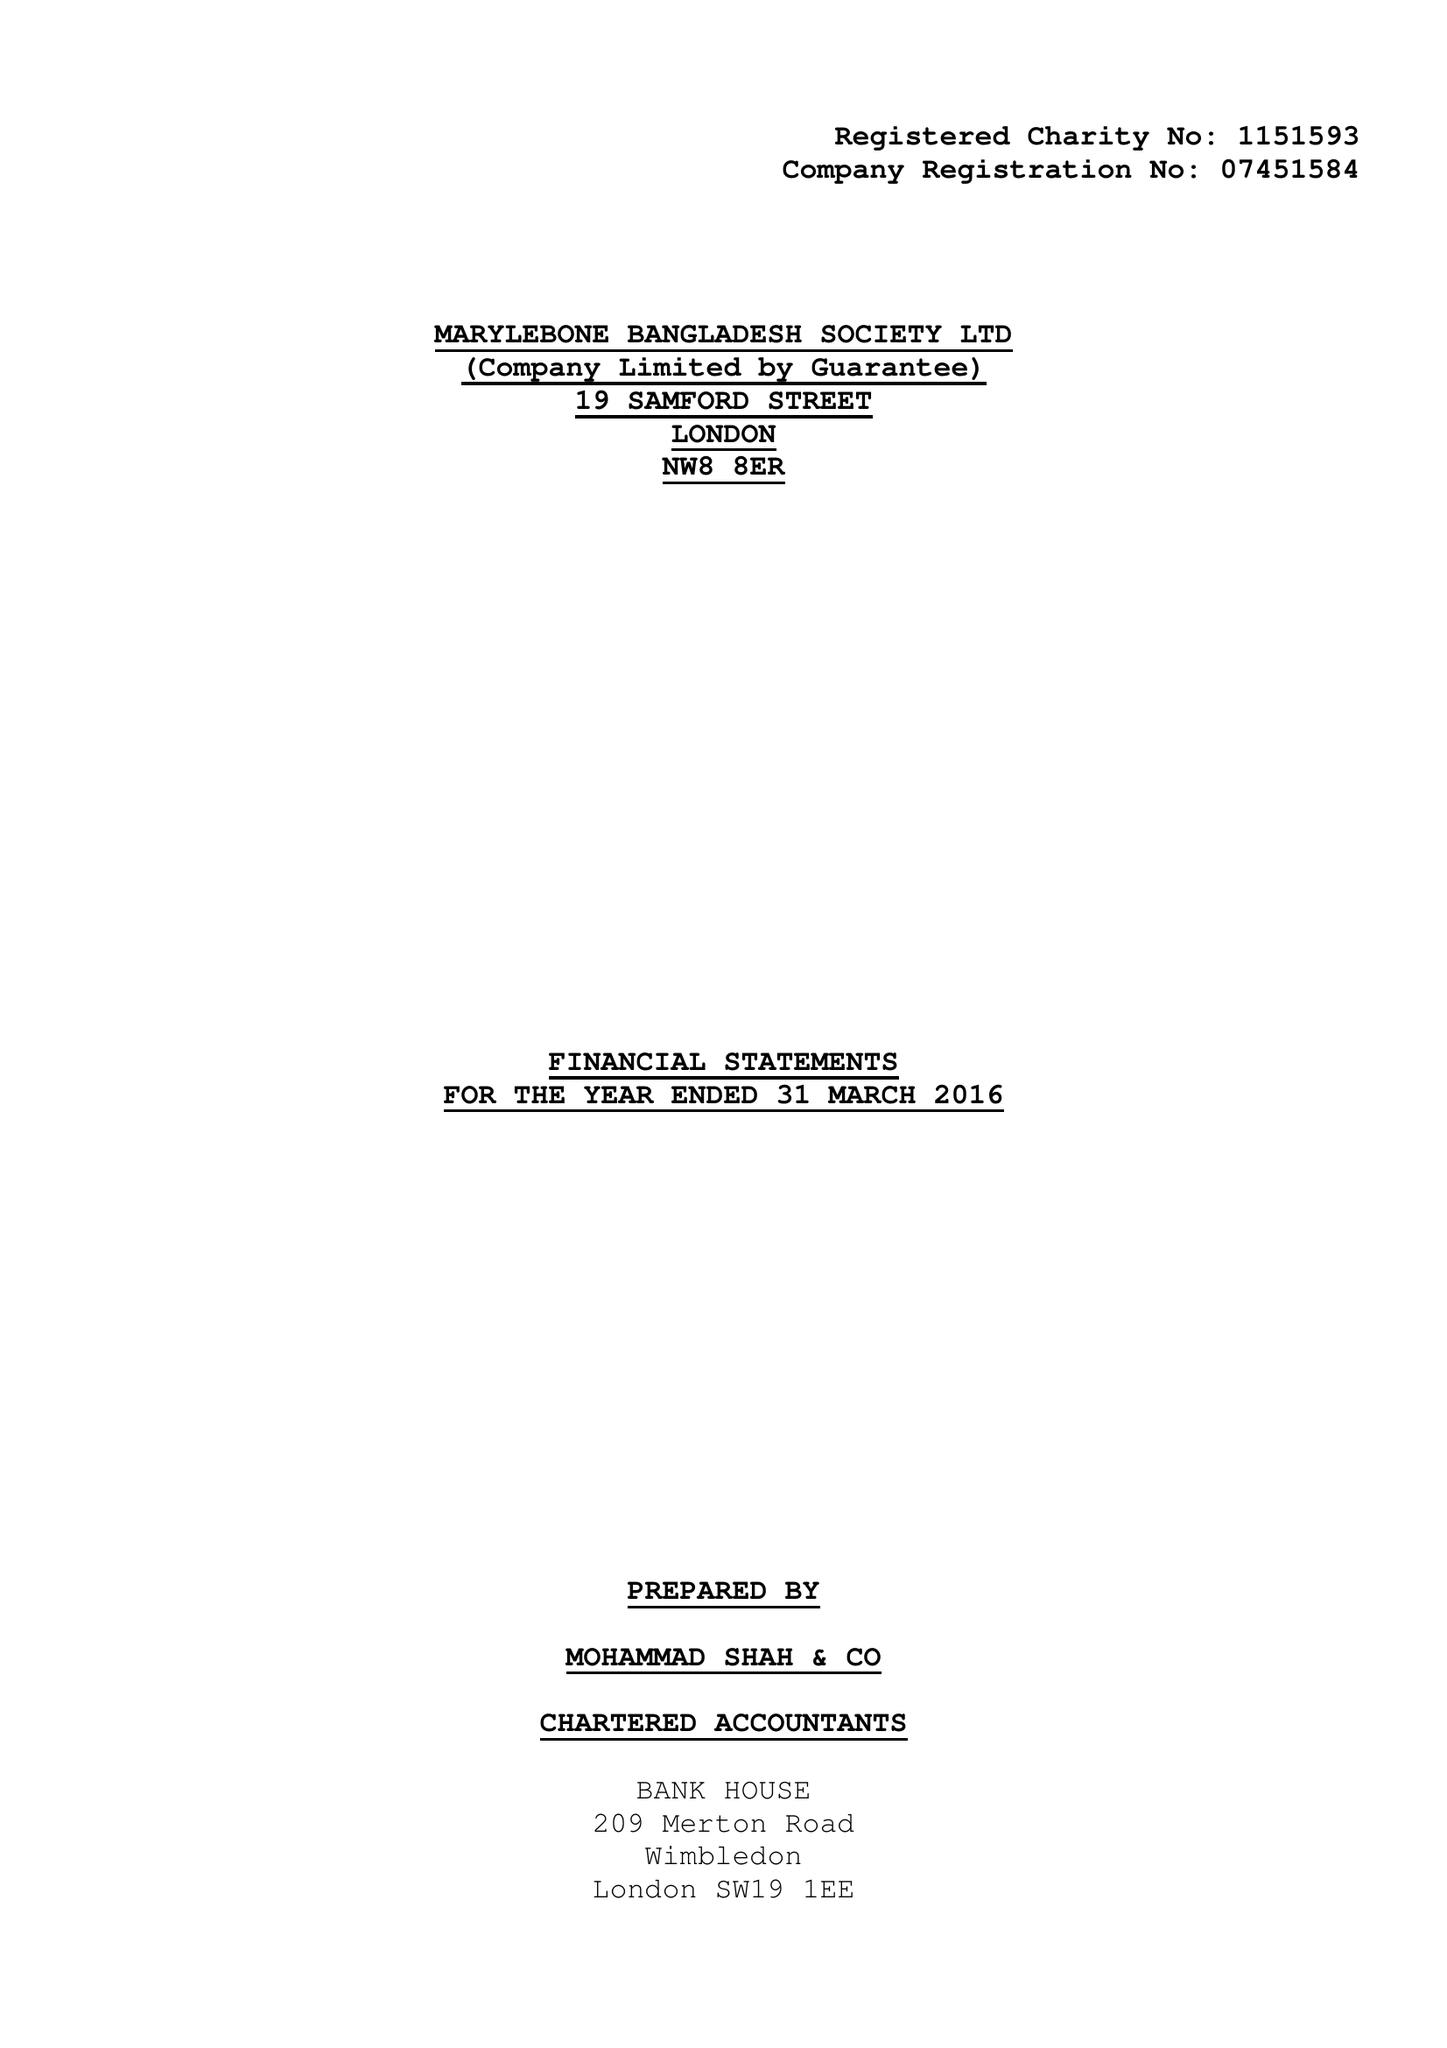What is the value for the report_date?
Answer the question using a single word or phrase. 2016-03-31 